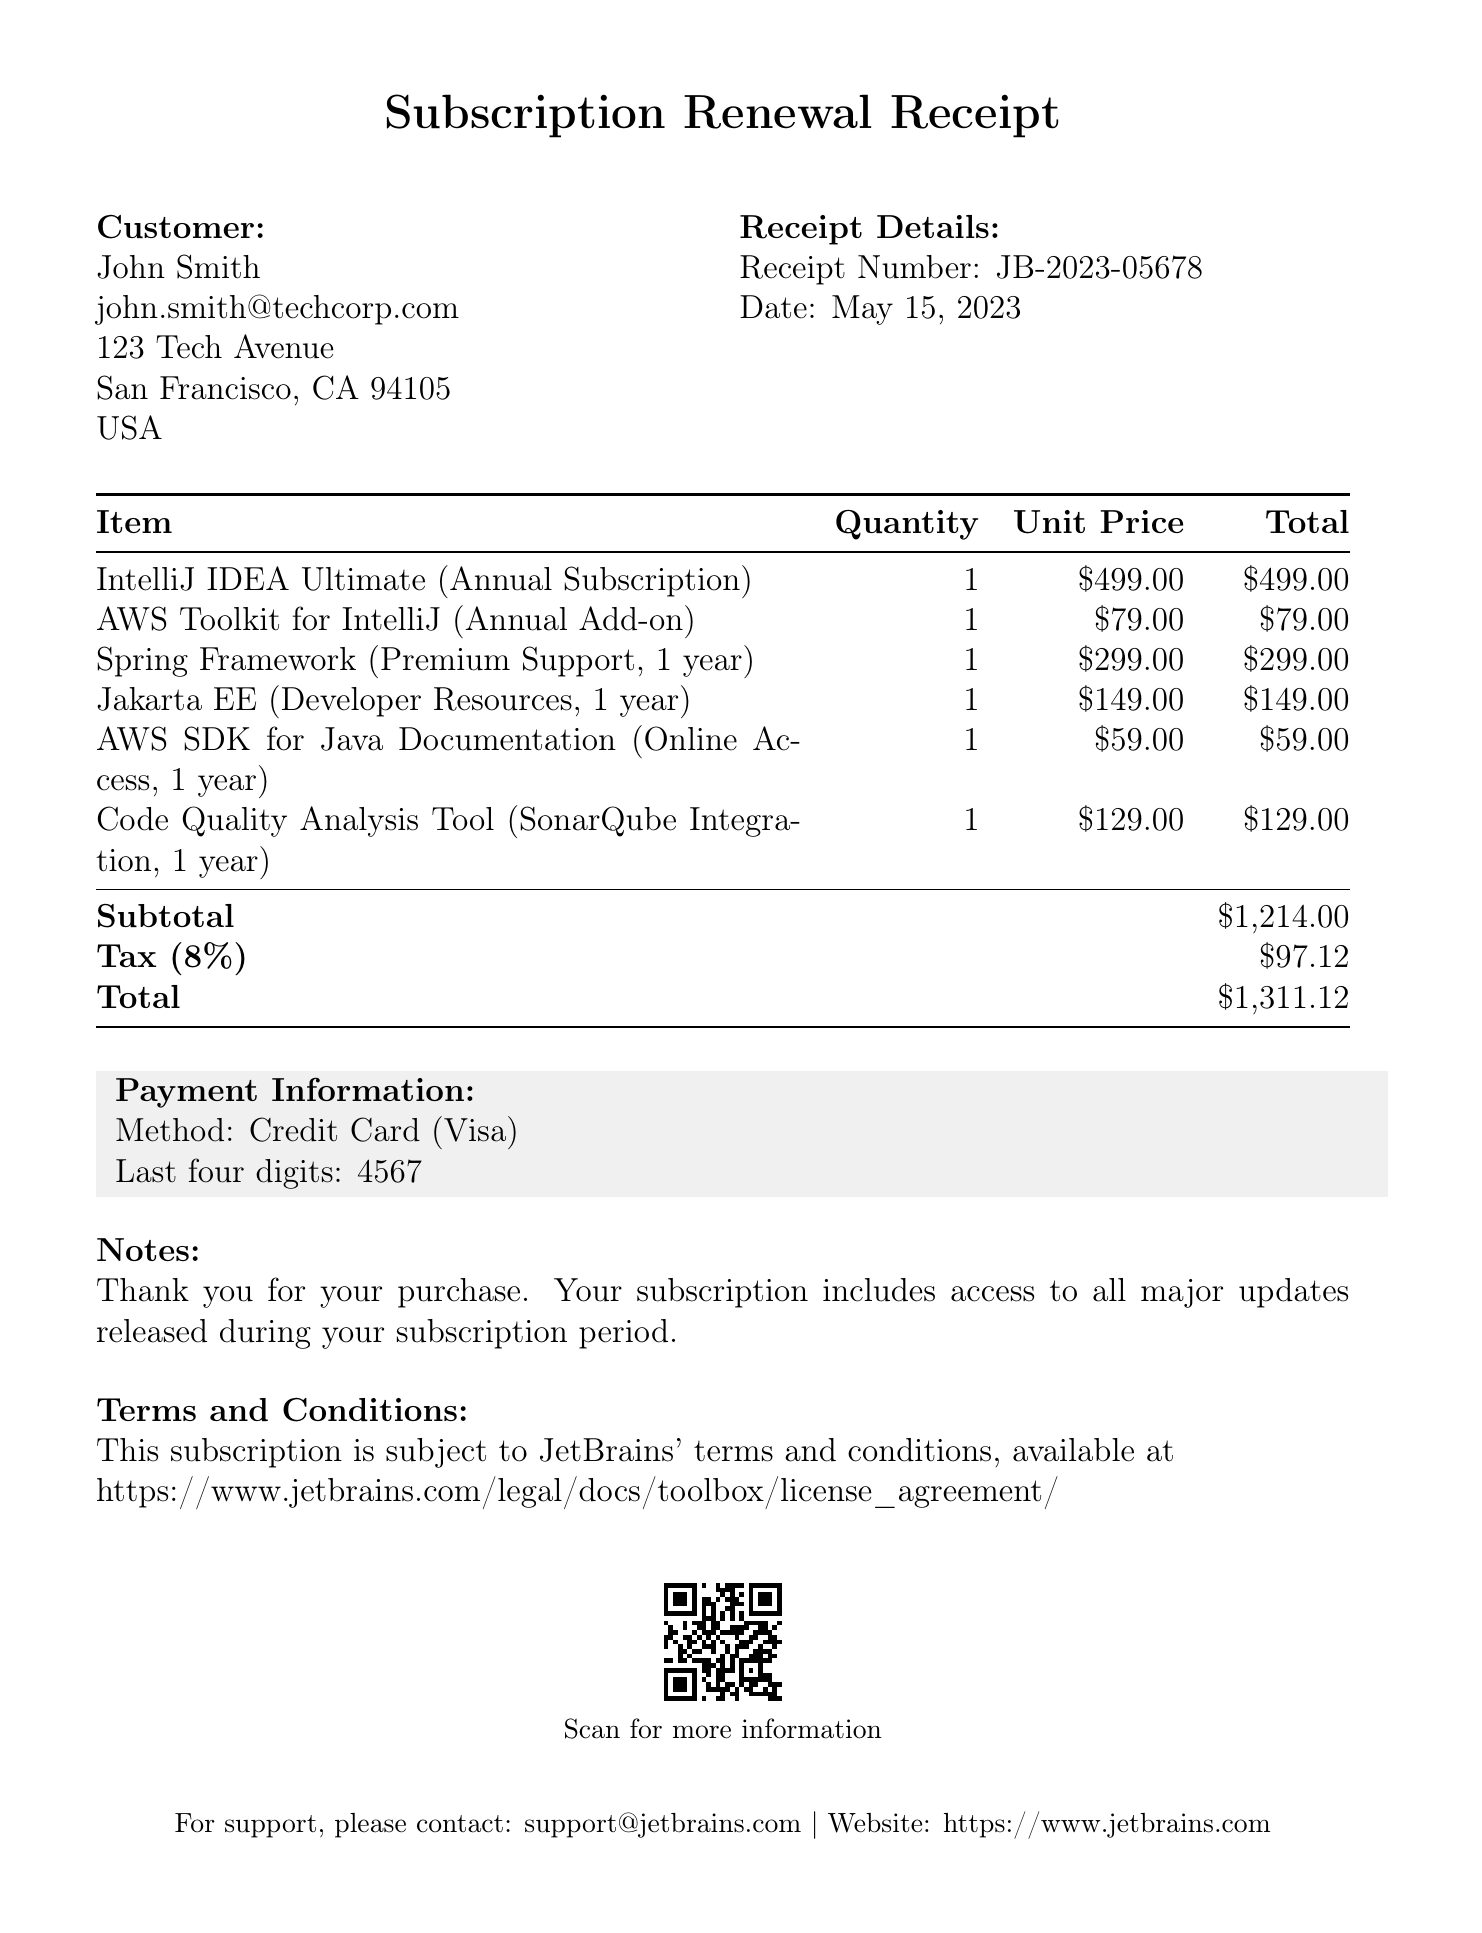what is the receipt number? The receipt number is listed under receipt details, identifying this particular transaction.
Answer: JB-2023-05678 who is the customer? The customer's name is mentioned at the beginning of the receipt.
Answer: John Smith what is the total amount due? The total amount is calculated by adding the subtotal and the tax amount.
Answer: $1,311.12 how many products were subscribed? The number of distinct subscription products is indicated in the subscription details section.
Answer: 2 what type of payment method was used? The payment method is specified within the payment information section of the document.
Answer: Credit Card what is the license type for IntelliJ IDEA Ultimate? The license type for this product is directly mentioned in the subscription details table.
Answer: Annual Subscription how much does access to the Spring Framework cost? The cost for accessing the Spring Framework is stated in the framework access section of the receipt.
Answer: $299.00 what is the duration of the AWS SDK for Java Documentation access? The duration for accessing this documentation is clearly specified in the additional services section.
Answer: 1 year where can the terms and conditions be found? The location of the terms and conditions is provided at the end of the document.
Answer: https://www.jetbrains.com/legal/docs/toolbox/license_agreement/ 